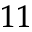Convert formula to latex. <formula><loc_0><loc_0><loc_500><loc_500>_ { 1 1 }</formula> 